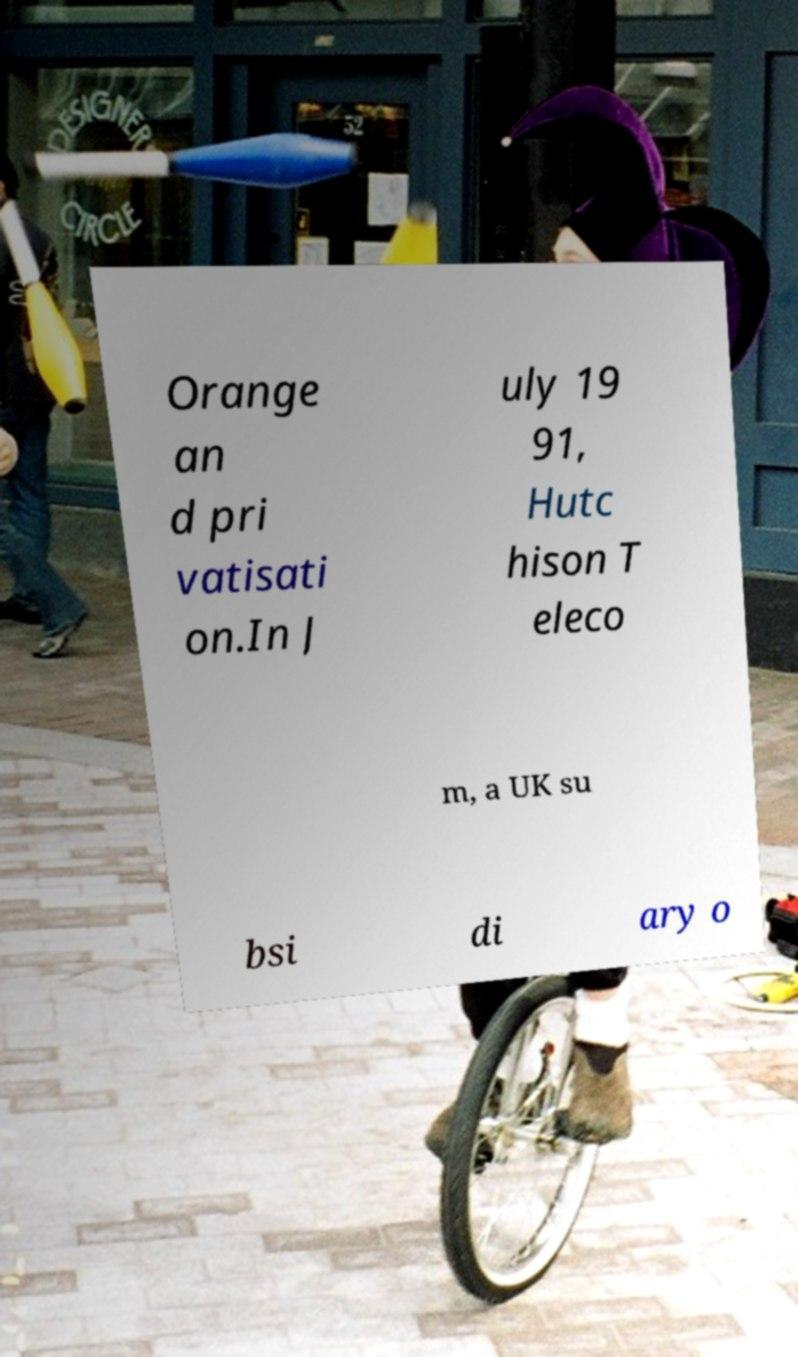What messages or text are displayed in this image? I need them in a readable, typed format. Orange an d pri vatisati on.In J uly 19 91, Hutc hison T eleco m, a UK su bsi di ary o 